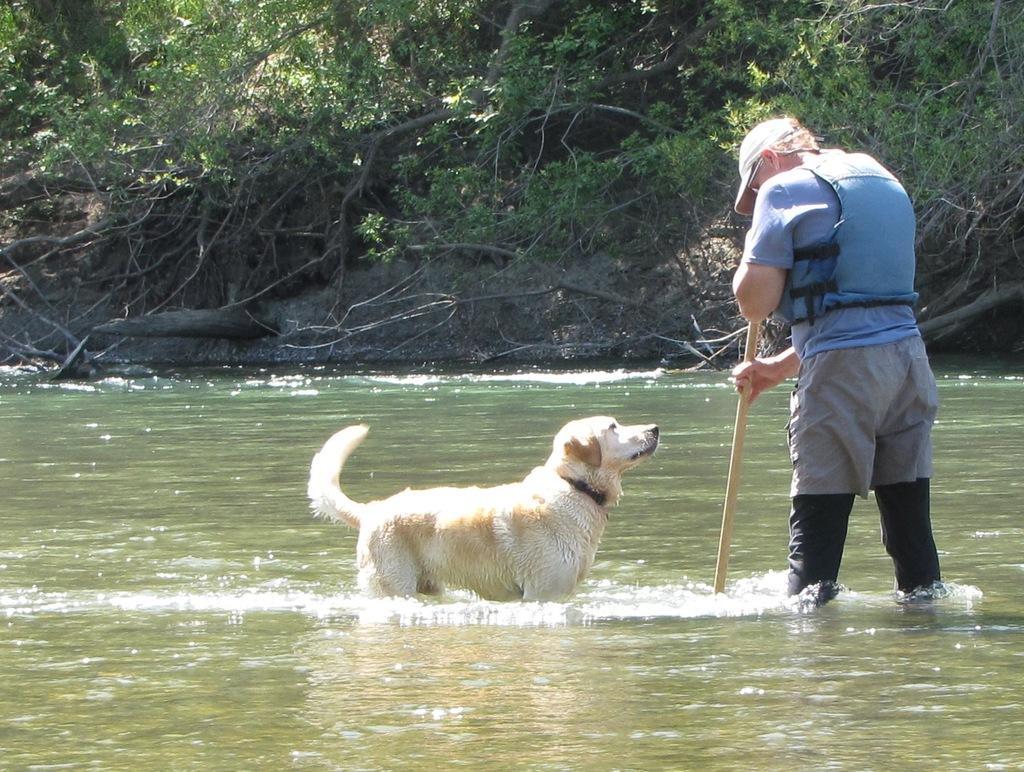Could you give a brief overview of what you see in this image? In this image I can see a dog which is cream and white in color is standing in the water and a person wearing blue jacket, grey pant is standing in the water and holding a stick. In the background I can see few trees and the water. 